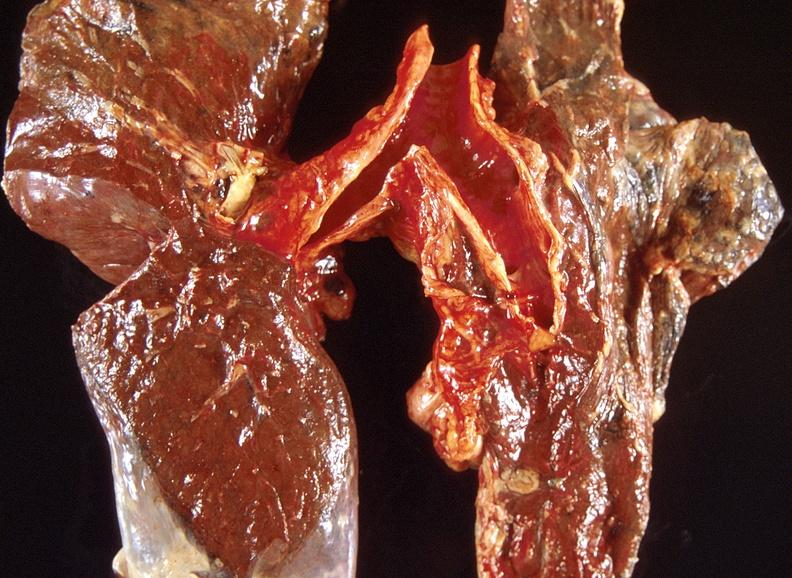what does this image show?
Answer the question using a single word or phrase. Lung carcinoma 